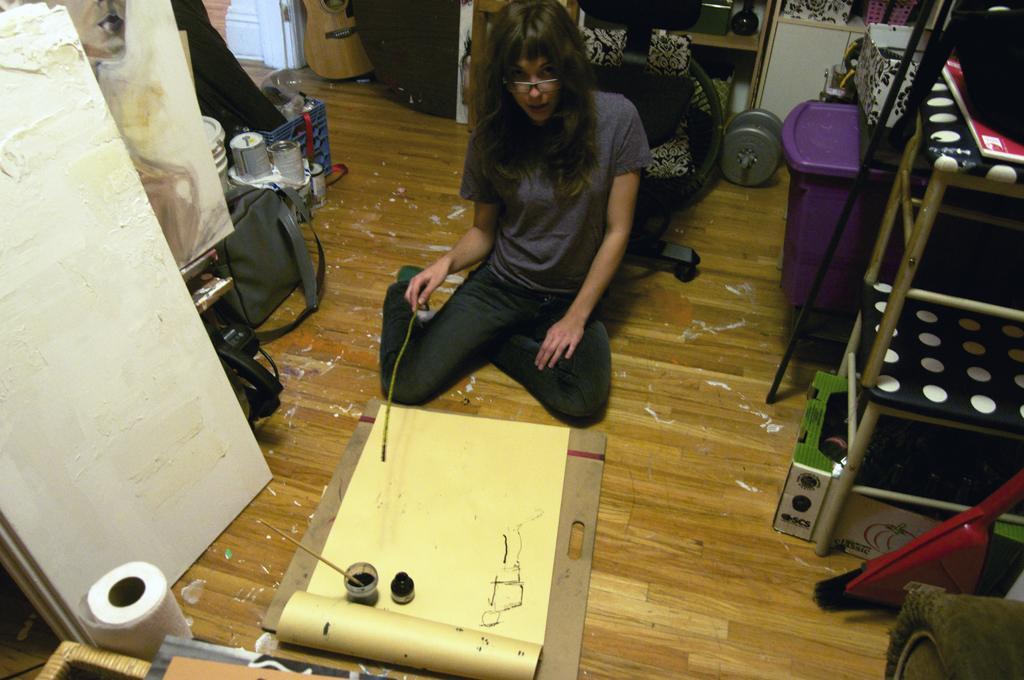How would you summarize this image in a sentence or two? In this image there is a person sitting on the floor and she is holding the stick. Around her there are a few objects. 